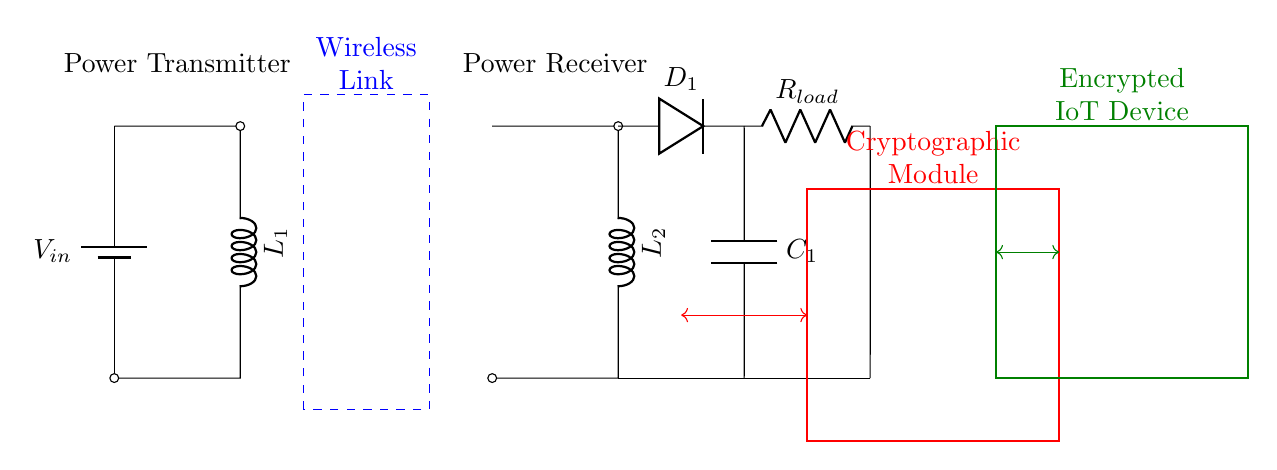What is the input voltage of the circuit? The input voltage is depicted by the label \(V_{in}\) next to the battery symbol in the circuit diagram.
Answer: \(V_{in}\) What components are present on the transmitter side? The transmitter side includes a battery and an inductor labeled \(L_1\) along with a short connection.
Answer: Battery, inductor \(L_1\) What does the dashed rectangle represent in the diagram? The dashed rectangle is labeled "Wireless Link," indicating the area where wireless power transfer occurs between the transmitter and receiver.
Answer: Wireless Link How many inductors are in this circuit? There are two inductors in the circuit: \(L_1\) on the transmitter side and \(L_2\) on the receiver side.
Answer: Two What is the role of the cryptographic module in this circuit? The cryptographic module, indicated by the red rectangle, is responsible for performing cryptographic operations to secure communications and power transfer to the IoT device.
Answer: Secure communication What is connected to the load \(R_{load}\) in this circuit? The load \(R_{load}\) is connected in series to the receiver side, receiving power from the circuit output through the capacitor \(C_1\).
Answer: Capacitor \(C_1\) and load \(R_{load}\) How does the power flow from the transmitter to the encrypted IoT device? Power flows wirelessly from the inductor \(L_1\), through the wireless link, to inductor \(L_2\), then through the cryptographic module before reaching the encrypted IoT device.
Answer: Inductor \(L_1\) to wireless link to inductor \(L_2\) to cryptographic module to IoT device 